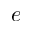<formula> <loc_0><loc_0><loc_500><loc_500>e</formula> 